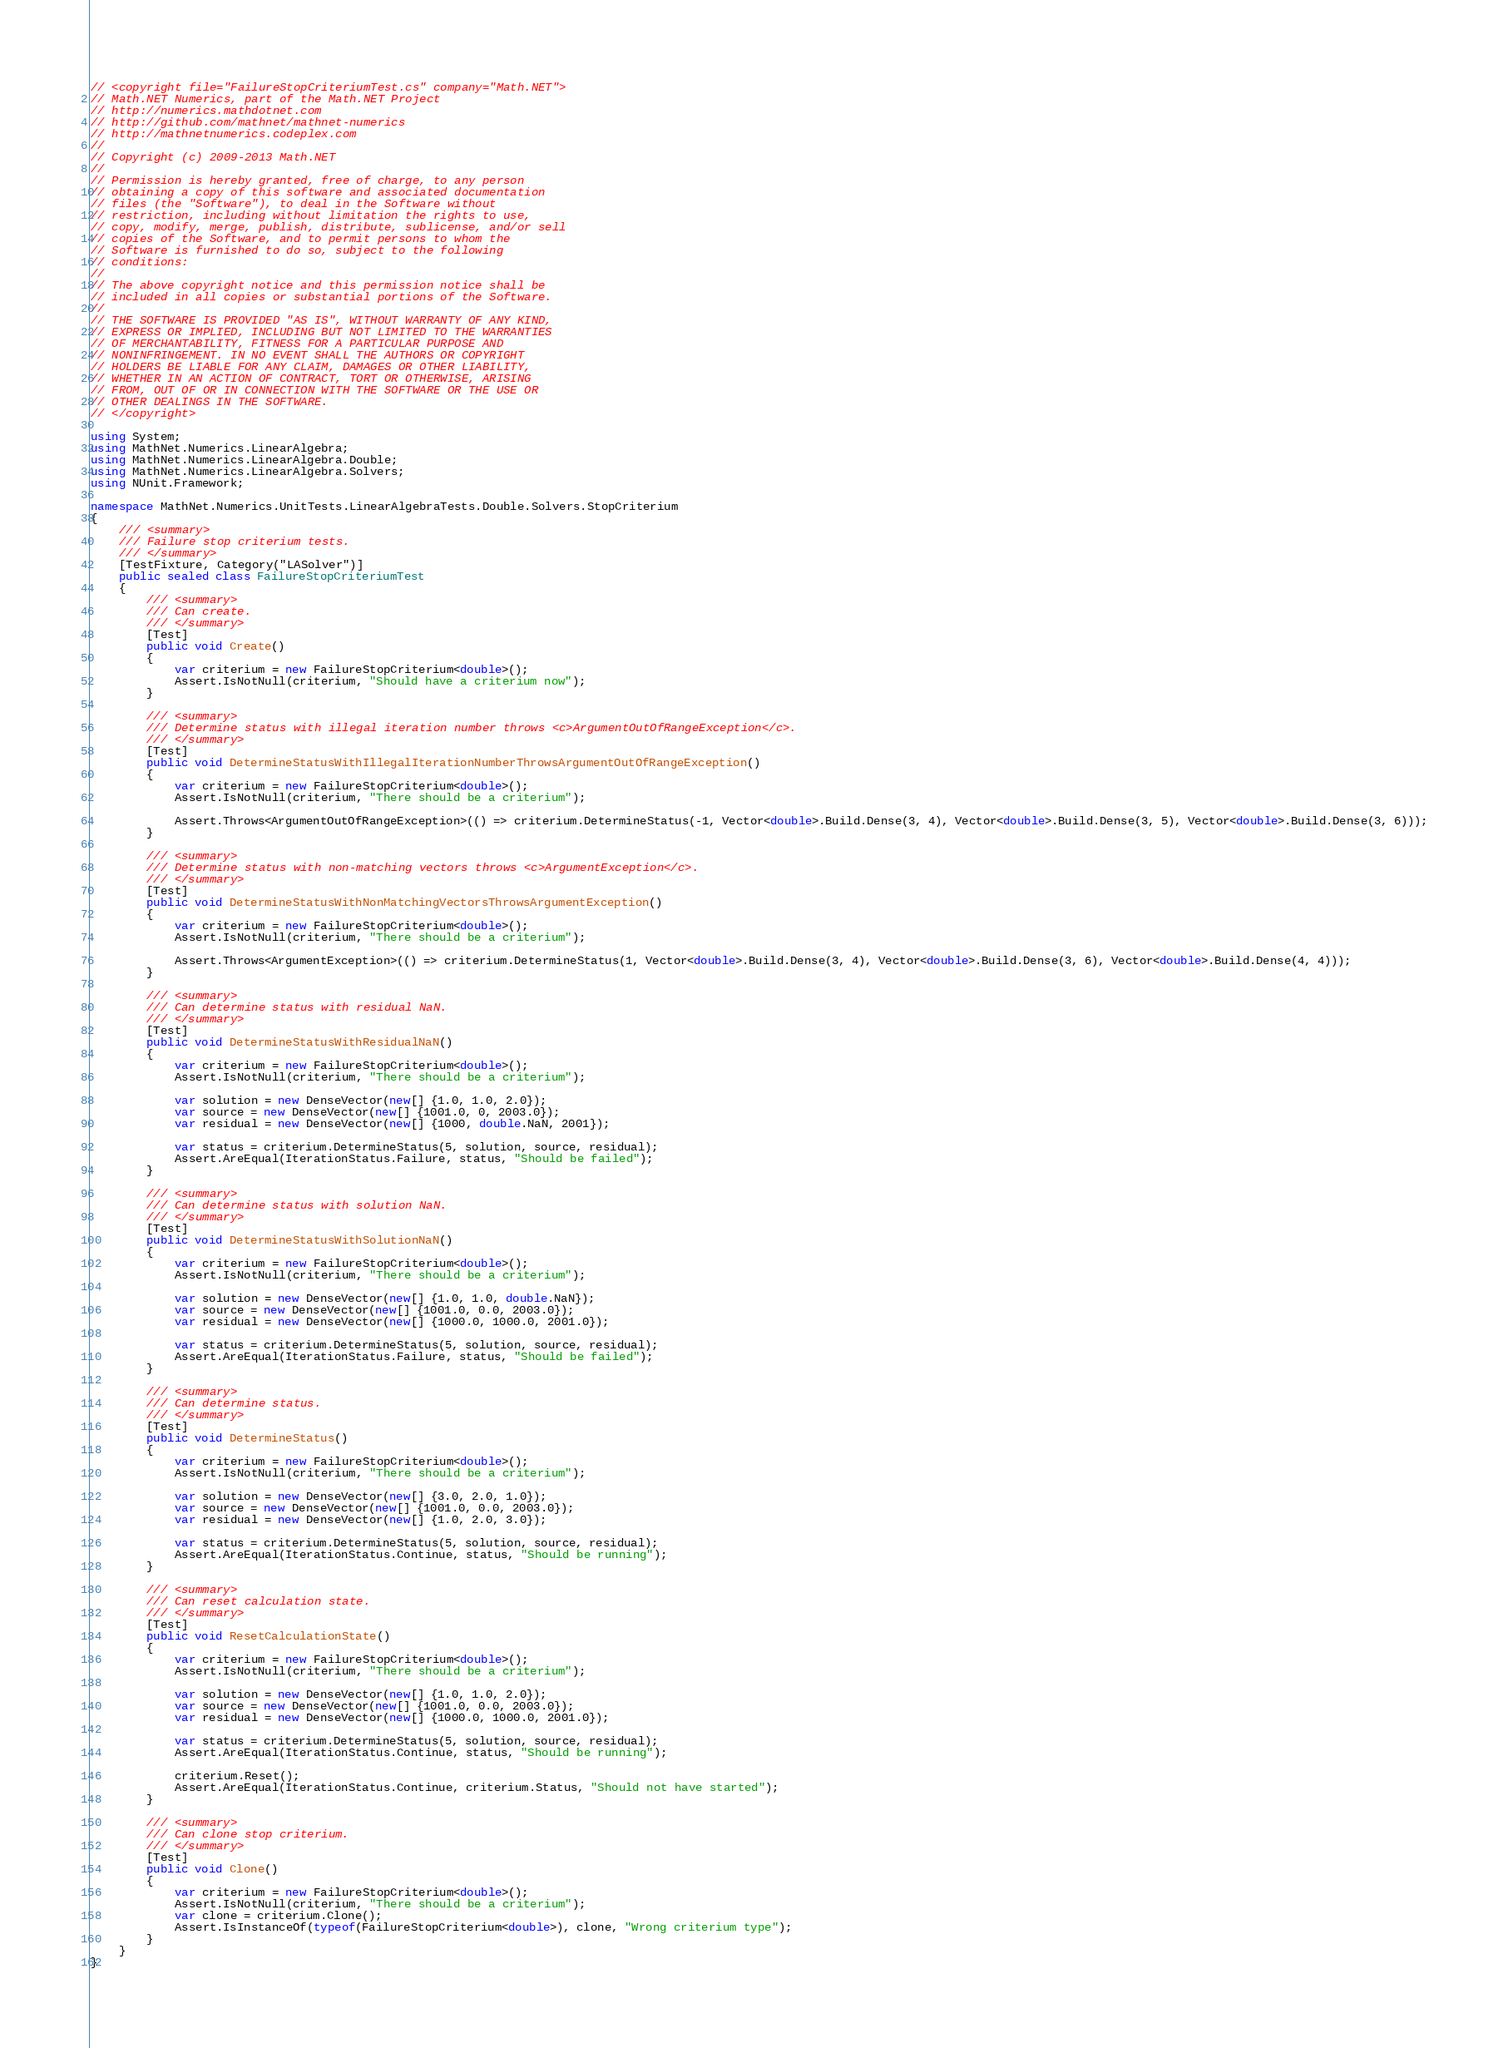<code> <loc_0><loc_0><loc_500><loc_500><_C#_>// <copyright file="FailureStopCriteriumTest.cs" company="Math.NET">
// Math.NET Numerics, part of the Math.NET Project
// http://numerics.mathdotnet.com
// http://github.com/mathnet/mathnet-numerics
// http://mathnetnumerics.codeplex.com
//
// Copyright (c) 2009-2013 Math.NET
//
// Permission is hereby granted, free of charge, to any person
// obtaining a copy of this software and associated documentation
// files (the "Software"), to deal in the Software without
// restriction, including without limitation the rights to use,
// copy, modify, merge, publish, distribute, sublicense, and/or sell
// copies of the Software, and to permit persons to whom the
// Software is furnished to do so, subject to the following
// conditions:
//
// The above copyright notice and this permission notice shall be
// included in all copies or substantial portions of the Software.
//
// THE SOFTWARE IS PROVIDED "AS IS", WITHOUT WARRANTY OF ANY KIND,
// EXPRESS OR IMPLIED, INCLUDING BUT NOT LIMITED TO THE WARRANTIES
// OF MERCHANTABILITY, FITNESS FOR A PARTICULAR PURPOSE AND
// NONINFRINGEMENT. IN NO EVENT SHALL THE AUTHORS OR COPYRIGHT
// HOLDERS BE LIABLE FOR ANY CLAIM, DAMAGES OR OTHER LIABILITY,
// WHETHER IN AN ACTION OF CONTRACT, TORT OR OTHERWISE, ARISING
// FROM, OUT OF OR IN CONNECTION WITH THE SOFTWARE OR THE USE OR
// OTHER DEALINGS IN THE SOFTWARE.
// </copyright>

using System;
using MathNet.Numerics.LinearAlgebra;
using MathNet.Numerics.LinearAlgebra.Double;
using MathNet.Numerics.LinearAlgebra.Solvers;
using NUnit.Framework;

namespace MathNet.Numerics.UnitTests.LinearAlgebraTests.Double.Solvers.StopCriterium
{
    /// <summary>
    /// Failure stop criterium tests.
    /// </summary>
    [TestFixture, Category("LASolver")]
    public sealed class FailureStopCriteriumTest
    {
        /// <summary>
        /// Can create.
        /// </summary>
        [Test]
        public void Create()
        {
            var criterium = new FailureStopCriterium<double>();
            Assert.IsNotNull(criterium, "Should have a criterium now");
        }

        /// <summary>
        /// Determine status with illegal iteration number throws <c>ArgumentOutOfRangeException</c>.
        /// </summary>
        [Test]
        public void DetermineStatusWithIllegalIterationNumberThrowsArgumentOutOfRangeException()
        {
            var criterium = new FailureStopCriterium<double>();
            Assert.IsNotNull(criterium, "There should be a criterium");

            Assert.Throws<ArgumentOutOfRangeException>(() => criterium.DetermineStatus(-1, Vector<double>.Build.Dense(3, 4), Vector<double>.Build.Dense(3, 5), Vector<double>.Build.Dense(3, 6)));
        }

        /// <summary>
        /// Determine status with non-matching vectors throws <c>ArgumentException</c>.
        /// </summary>
        [Test]
        public void DetermineStatusWithNonMatchingVectorsThrowsArgumentException()
        {
            var criterium = new FailureStopCriterium<double>();
            Assert.IsNotNull(criterium, "There should be a criterium");

            Assert.Throws<ArgumentException>(() => criterium.DetermineStatus(1, Vector<double>.Build.Dense(3, 4), Vector<double>.Build.Dense(3, 6), Vector<double>.Build.Dense(4, 4)));
        }

        /// <summary>
        /// Can determine status with residual NaN.
        /// </summary>
        [Test]
        public void DetermineStatusWithResidualNaN()
        {
            var criterium = new FailureStopCriterium<double>();
            Assert.IsNotNull(criterium, "There should be a criterium");

            var solution = new DenseVector(new[] {1.0, 1.0, 2.0});
            var source = new DenseVector(new[] {1001.0, 0, 2003.0});
            var residual = new DenseVector(new[] {1000, double.NaN, 2001});

            var status = criterium.DetermineStatus(5, solution, source, residual);
            Assert.AreEqual(IterationStatus.Failure, status, "Should be failed");
        }

        /// <summary>
        /// Can determine status with solution NaN.
        /// </summary>
        [Test]
        public void DetermineStatusWithSolutionNaN()
        {
            var criterium = new FailureStopCriterium<double>();
            Assert.IsNotNull(criterium, "There should be a criterium");

            var solution = new DenseVector(new[] {1.0, 1.0, double.NaN});
            var source = new DenseVector(new[] {1001.0, 0.0, 2003.0});
            var residual = new DenseVector(new[] {1000.0, 1000.0, 2001.0});

            var status = criterium.DetermineStatus(5, solution, source, residual);
            Assert.AreEqual(IterationStatus.Failure, status, "Should be failed");
        }

        /// <summary>
        /// Can determine status.
        /// </summary>
        [Test]
        public void DetermineStatus()
        {
            var criterium = new FailureStopCriterium<double>();
            Assert.IsNotNull(criterium, "There should be a criterium");

            var solution = new DenseVector(new[] {3.0, 2.0, 1.0});
            var source = new DenseVector(new[] {1001.0, 0.0, 2003.0});
            var residual = new DenseVector(new[] {1.0, 2.0, 3.0});

            var status = criterium.DetermineStatus(5, solution, source, residual);
            Assert.AreEqual(IterationStatus.Continue, status, "Should be running");
        }

        /// <summary>
        /// Can reset calculation state.
        /// </summary>
        [Test]
        public void ResetCalculationState()
        {
            var criterium = new FailureStopCriterium<double>();
            Assert.IsNotNull(criterium, "There should be a criterium");

            var solution = new DenseVector(new[] {1.0, 1.0, 2.0});
            var source = new DenseVector(new[] {1001.0, 0.0, 2003.0});
            var residual = new DenseVector(new[] {1000.0, 1000.0, 2001.0});

            var status = criterium.DetermineStatus(5, solution, source, residual);
            Assert.AreEqual(IterationStatus.Continue, status, "Should be running");

            criterium.Reset();
            Assert.AreEqual(IterationStatus.Continue, criterium.Status, "Should not have started");
        }

        /// <summary>
        /// Can clone stop criterium.
        /// </summary>
        [Test]
        public void Clone()
        {
            var criterium = new FailureStopCriterium<double>();
            Assert.IsNotNull(criterium, "There should be a criterium");
            var clone = criterium.Clone();
            Assert.IsInstanceOf(typeof(FailureStopCriterium<double>), clone, "Wrong criterium type");
        }
    }
}
</code> 